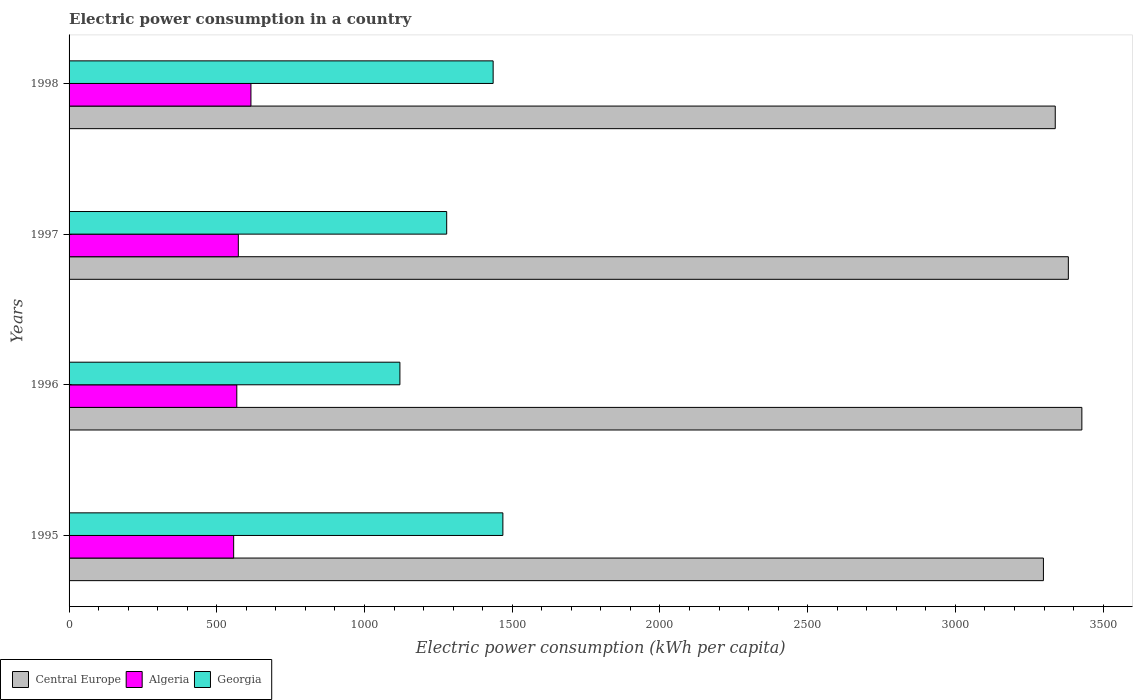How many different coloured bars are there?
Offer a very short reply. 3. How many groups of bars are there?
Your response must be concise. 4. Are the number of bars per tick equal to the number of legend labels?
Your answer should be compact. Yes. Are the number of bars on each tick of the Y-axis equal?
Give a very brief answer. Yes. How many bars are there on the 3rd tick from the bottom?
Offer a terse response. 3. What is the label of the 1st group of bars from the top?
Your response must be concise. 1998. What is the electric power consumption in in Georgia in 1995?
Offer a very short reply. 1468.31. Across all years, what is the maximum electric power consumption in in Georgia?
Make the answer very short. 1468.31. Across all years, what is the minimum electric power consumption in in Algeria?
Your answer should be very brief. 557.08. In which year was the electric power consumption in in Georgia maximum?
Provide a succinct answer. 1995. In which year was the electric power consumption in in Georgia minimum?
Ensure brevity in your answer.  1996. What is the total electric power consumption in in Central Europe in the graph?
Make the answer very short. 1.34e+04. What is the difference between the electric power consumption in in Algeria in 1997 and that in 1998?
Your answer should be compact. -42.64. What is the difference between the electric power consumption in in Central Europe in 1996 and the electric power consumption in in Algeria in 1998?
Offer a terse response. 2812.43. What is the average electric power consumption in in Algeria per year?
Your response must be concise. 578.31. In the year 1998, what is the difference between the electric power consumption in in Algeria and electric power consumption in in Central Europe?
Give a very brief answer. -2722.41. In how many years, is the electric power consumption in in Algeria greater than 2400 kWh per capita?
Provide a succinct answer. 0. What is the ratio of the electric power consumption in in Georgia in 1995 to that in 1998?
Your answer should be compact. 1.02. What is the difference between the highest and the second highest electric power consumption in in Central Europe?
Your answer should be compact. 45.7. What is the difference between the highest and the lowest electric power consumption in in Central Europe?
Provide a short and direct response. 130.07. In how many years, is the electric power consumption in in Georgia greater than the average electric power consumption in in Georgia taken over all years?
Keep it short and to the point. 2. Is the sum of the electric power consumption in in Algeria in 1995 and 1998 greater than the maximum electric power consumption in in Georgia across all years?
Offer a terse response. No. What does the 3rd bar from the top in 1996 represents?
Ensure brevity in your answer.  Central Europe. What does the 2nd bar from the bottom in 1995 represents?
Give a very brief answer. Algeria. Is it the case that in every year, the sum of the electric power consumption in in Central Europe and electric power consumption in in Algeria is greater than the electric power consumption in in Georgia?
Your response must be concise. Yes. How many bars are there?
Your answer should be compact. 12. Are all the bars in the graph horizontal?
Provide a short and direct response. Yes. Does the graph contain any zero values?
Give a very brief answer. No. Does the graph contain grids?
Offer a terse response. No. What is the title of the graph?
Provide a succinct answer. Electric power consumption in a country. Does "Finland" appear as one of the legend labels in the graph?
Your answer should be compact. No. What is the label or title of the X-axis?
Offer a very short reply. Electric power consumption (kWh per capita). What is the Electric power consumption (kWh per capita) of Central Europe in 1995?
Your answer should be very brief. 3297.92. What is the Electric power consumption (kWh per capita) in Algeria in 1995?
Your answer should be compact. 557.08. What is the Electric power consumption (kWh per capita) of Georgia in 1995?
Make the answer very short. 1468.31. What is the Electric power consumption (kWh per capita) of Central Europe in 1996?
Your answer should be very brief. 3427.99. What is the Electric power consumption (kWh per capita) in Algeria in 1996?
Give a very brief answer. 567.7. What is the Electric power consumption (kWh per capita) in Georgia in 1996?
Provide a short and direct response. 1119.78. What is the Electric power consumption (kWh per capita) in Central Europe in 1997?
Your response must be concise. 3382.29. What is the Electric power consumption (kWh per capita) of Algeria in 1997?
Keep it short and to the point. 572.91. What is the Electric power consumption (kWh per capita) of Georgia in 1997?
Provide a succinct answer. 1278.14. What is the Electric power consumption (kWh per capita) of Central Europe in 1998?
Offer a terse response. 3337.97. What is the Electric power consumption (kWh per capita) of Algeria in 1998?
Your answer should be compact. 615.55. What is the Electric power consumption (kWh per capita) in Georgia in 1998?
Ensure brevity in your answer.  1435.38. Across all years, what is the maximum Electric power consumption (kWh per capita) in Central Europe?
Offer a very short reply. 3427.99. Across all years, what is the maximum Electric power consumption (kWh per capita) in Algeria?
Your answer should be very brief. 615.55. Across all years, what is the maximum Electric power consumption (kWh per capita) in Georgia?
Your answer should be very brief. 1468.31. Across all years, what is the minimum Electric power consumption (kWh per capita) in Central Europe?
Your answer should be very brief. 3297.92. Across all years, what is the minimum Electric power consumption (kWh per capita) in Algeria?
Your response must be concise. 557.08. Across all years, what is the minimum Electric power consumption (kWh per capita) in Georgia?
Offer a very short reply. 1119.78. What is the total Electric power consumption (kWh per capita) of Central Europe in the graph?
Make the answer very short. 1.34e+04. What is the total Electric power consumption (kWh per capita) in Algeria in the graph?
Your answer should be very brief. 2313.24. What is the total Electric power consumption (kWh per capita) of Georgia in the graph?
Your answer should be very brief. 5301.61. What is the difference between the Electric power consumption (kWh per capita) in Central Europe in 1995 and that in 1996?
Keep it short and to the point. -130.07. What is the difference between the Electric power consumption (kWh per capita) of Algeria in 1995 and that in 1996?
Your answer should be very brief. -10.62. What is the difference between the Electric power consumption (kWh per capita) in Georgia in 1995 and that in 1996?
Provide a short and direct response. 348.54. What is the difference between the Electric power consumption (kWh per capita) of Central Europe in 1995 and that in 1997?
Offer a terse response. -84.37. What is the difference between the Electric power consumption (kWh per capita) of Algeria in 1995 and that in 1997?
Keep it short and to the point. -15.83. What is the difference between the Electric power consumption (kWh per capita) in Georgia in 1995 and that in 1997?
Offer a very short reply. 190.18. What is the difference between the Electric power consumption (kWh per capita) of Central Europe in 1995 and that in 1998?
Provide a succinct answer. -40.05. What is the difference between the Electric power consumption (kWh per capita) of Algeria in 1995 and that in 1998?
Your response must be concise. -58.47. What is the difference between the Electric power consumption (kWh per capita) of Georgia in 1995 and that in 1998?
Keep it short and to the point. 32.93. What is the difference between the Electric power consumption (kWh per capita) of Central Europe in 1996 and that in 1997?
Ensure brevity in your answer.  45.7. What is the difference between the Electric power consumption (kWh per capita) in Algeria in 1996 and that in 1997?
Your response must be concise. -5.21. What is the difference between the Electric power consumption (kWh per capita) in Georgia in 1996 and that in 1997?
Make the answer very short. -158.36. What is the difference between the Electric power consumption (kWh per capita) of Central Europe in 1996 and that in 1998?
Your answer should be very brief. 90.02. What is the difference between the Electric power consumption (kWh per capita) of Algeria in 1996 and that in 1998?
Offer a terse response. -47.86. What is the difference between the Electric power consumption (kWh per capita) of Georgia in 1996 and that in 1998?
Keep it short and to the point. -315.61. What is the difference between the Electric power consumption (kWh per capita) in Central Europe in 1997 and that in 1998?
Your response must be concise. 44.32. What is the difference between the Electric power consumption (kWh per capita) of Algeria in 1997 and that in 1998?
Your answer should be very brief. -42.64. What is the difference between the Electric power consumption (kWh per capita) of Georgia in 1997 and that in 1998?
Ensure brevity in your answer.  -157.25. What is the difference between the Electric power consumption (kWh per capita) in Central Europe in 1995 and the Electric power consumption (kWh per capita) in Algeria in 1996?
Your answer should be compact. 2730.22. What is the difference between the Electric power consumption (kWh per capita) in Central Europe in 1995 and the Electric power consumption (kWh per capita) in Georgia in 1996?
Your answer should be compact. 2178.14. What is the difference between the Electric power consumption (kWh per capita) in Algeria in 1995 and the Electric power consumption (kWh per capita) in Georgia in 1996?
Make the answer very short. -562.7. What is the difference between the Electric power consumption (kWh per capita) in Central Europe in 1995 and the Electric power consumption (kWh per capita) in Algeria in 1997?
Keep it short and to the point. 2725.01. What is the difference between the Electric power consumption (kWh per capita) in Central Europe in 1995 and the Electric power consumption (kWh per capita) in Georgia in 1997?
Provide a short and direct response. 2019.78. What is the difference between the Electric power consumption (kWh per capita) of Algeria in 1995 and the Electric power consumption (kWh per capita) of Georgia in 1997?
Give a very brief answer. -721.06. What is the difference between the Electric power consumption (kWh per capita) of Central Europe in 1995 and the Electric power consumption (kWh per capita) of Algeria in 1998?
Offer a terse response. 2682.37. What is the difference between the Electric power consumption (kWh per capita) in Central Europe in 1995 and the Electric power consumption (kWh per capita) in Georgia in 1998?
Provide a short and direct response. 1862.54. What is the difference between the Electric power consumption (kWh per capita) of Algeria in 1995 and the Electric power consumption (kWh per capita) of Georgia in 1998?
Give a very brief answer. -878.3. What is the difference between the Electric power consumption (kWh per capita) of Central Europe in 1996 and the Electric power consumption (kWh per capita) of Algeria in 1997?
Provide a succinct answer. 2855.08. What is the difference between the Electric power consumption (kWh per capita) in Central Europe in 1996 and the Electric power consumption (kWh per capita) in Georgia in 1997?
Keep it short and to the point. 2149.85. What is the difference between the Electric power consumption (kWh per capita) of Algeria in 1996 and the Electric power consumption (kWh per capita) of Georgia in 1997?
Provide a short and direct response. -710.44. What is the difference between the Electric power consumption (kWh per capita) in Central Europe in 1996 and the Electric power consumption (kWh per capita) in Algeria in 1998?
Your response must be concise. 2812.43. What is the difference between the Electric power consumption (kWh per capita) of Central Europe in 1996 and the Electric power consumption (kWh per capita) of Georgia in 1998?
Ensure brevity in your answer.  1992.6. What is the difference between the Electric power consumption (kWh per capita) in Algeria in 1996 and the Electric power consumption (kWh per capita) in Georgia in 1998?
Give a very brief answer. -867.69. What is the difference between the Electric power consumption (kWh per capita) of Central Europe in 1997 and the Electric power consumption (kWh per capita) of Algeria in 1998?
Keep it short and to the point. 2766.73. What is the difference between the Electric power consumption (kWh per capita) of Central Europe in 1997 and the Electric power consumption (kWh per capita) of Georgia in 1998?
Make the answer very short. 1946.9. What is the difference between the Electric power consumption (kWh per capita) in Algeria in 1997 and the Electric power consumption (kWh per capita) in Georgia in 1998?
Your response must be concise. -862.47. What is the average Electric power consumption (kWh per capita) of Central Europe per year?
Your answer should be compact. 3361.54. What is the average Electric power consumption (kWh per capita) of Algeria per year?
Give a very brief answer. 578.31. What is the average Electric power consumption (kWh per capita) of Georgia per year?
Offer a very short reply. 1325.4. In the year 1995, what is the difference between the Electric power consumption (kWh per capita) of Central Europe and Electric power consumption (kWh per capita) of Algeria?
Provide a short and direct response. 2740.84. In the year 1995, what is the difference between the Electric power consumption (kWh per capita) of Central Europe and Electric power consumption (kWh per capita) of Georgia?
Your answer should be very brief. 1829.61. In the year 1995, what is the difference between the Electric power consumption (kWh per capita) of Algeria and Electric power consumption (kWh per capita) of Georgia?
Ensure brevity in your answer.  -911.23. In the year 1996, what is the difference between the Electric power consumption (kWh per capita) in Central Europe and Electric power consumption (kWh per capita) in Algeria?
Your answer should be very brief. 2860.29. In the year 1996, what is the difference between the Electric power consumption (kWh per capita) of Central Europe and Electric power consumption (kWh per capita) of Georgia?
Offer a terse response. 2308.21. In the year 1996, what is the difference between the Electric power consumption (kWh per capita) of Algeria and Electric power consumption (kWh per capita) of Georgia?
Give a very brief answer. -552.08. In the year 1997, what is the difference between the Electric power consumption (kWh per capita) of Central Europe and Electric power consumption (kWh per capita) of Algeria?
Your answer should be compact. 2809.38. In the year 1997, what is the difference between the Electric power consumption (kWh per capita) of Central Europe and Electric power consumption (kWh per capita) of Georgia?
Offer a very short reply. 2104.15. In the year 1997, what is the difference between the Electric power consumption (kWh per capita) in Algeria and Electric power consumption (kWh per capita) in Georgia?
Ensure brevity in your answer.  -705.22. In the year 1998, what is the difference between the Electric power consumption (kWh per capita) in Central Europe and Electric power consumption (kWh per capita) in Algeria?
Your answer should be very brief. 2722.41. In the year 1998, what is the difference between the Electric power consumption (kWh per capita) in Central Europe and Electric power consumption (kWh per capita) in Georgia?
Provide a succinct answer. 1902.58. In the year 1998, what is the difference between the Electric power consumption (kWh per capita) of Algeria and Electric power consumption (kWh per capita) of Georgia?
Provide a succinct answer. -819.83. What is the ratio of the Electric power consumption (kWh per capita) in Central Europe in 1995 to that in 1996?
Offer a terse response. 0.96. What is the ratio of the Electric power consumption (kWh per capita) of Algeria in 1995 to that in 1996?
Offer a very short reply. 0.98. What is the ratio of the Electric power consumption (kWh per capita) of Georgia in 1995 to that in 1996?
Offer a terse response. 1.31. What is the ratio of the Electric power consumption (kWh per capita) in Central Europe in 1995 to that in 1997?
Ensure brevity in your answer.  0.98. What is the ratio of the Electric power consumption (kWh per capita) in Algeria in 1995 to that in 1997?
Make the answer very short. 0.97. What is the ratio of the Electric power consumption (kWh per capita) in Georgia in 1995 to that in 1997?
Offer a terse response. 1.15. What is the ratio of the Electric power consumption (kWh per capita) of Algeria in 1995 to that in 1998?
Your response must be concise. 0.91. What is the ratio of the Electric power consumption (kWh per capita) of Georgia in 1995 to that in 1998?
Provide a short and direct response. 1.02. What is the ratio of the Electric power consumption (kWh per capita) in Central Europe in 1996 to that in 1997?
Offer a terse response. 1.01. What is the ratio of the Electric power consumption (kWh per capita) of Algeria in 1996 to that in 1997?
Provide a succinct answer. 0.99. What is the ratio of the Electric power consumption (kWh per capita) of Georgia in 1996 to that in 1997?
Provide a short and direct response. 0.88. What is the ratio of the Electric power consumption (kWh per capita) of Central Europe in 1996 to that in 1998?
Offer a very short reply. 1.03. What is the ratio of the Electric power consumption (kWh per capita) of Algeria in 1996 to that in 1998?
Offer a very short reply. 0.92. What is the ratio of the Electric power consumption (kWh per capita) of Georgia in 1996 to that in 1998?
Your response must be concise. 0.78. What is the ratio of the Electric power consumption (kWh per capita) of Central Europe in 1997 to that in 1998?
Ensure brevity in your answer.  1.01. What is the ratio of the Electric power consumption (kWh per capita) of Algeria in 1997 to that in 1998?
Give a very brief answer. 0.93. What is the ratio of the Electric power consumption (kWh per capita) in Georgia in 1997 to that in 1998?
Your response must be concise. 0.89. What is the difference between the highest and the second highest Electric power consumption (kWh per capita) in Central Europe?
Offer a terse response. 45.7. What is the difference between the highest and the second highest Electric power consumption (kWh per capita) in Algeria?
Your answer should be very brief. 42.64. What is the difference between the highest and the second highest Electric power consumption (kWh per capita) of Georgia?
Keep it short and to the point. 32.93. What is the difference between the highest and the lowest Electric power consumption (kWh per capita) of Central Europe?
Provide a short and direct response. 130.07. What is the difference between the highest and the lowest Electric power consumption (kWh per capita) of Algeria?
Ensure brevity in your answer.  58.47. What is the difference between the highest and the lowest Electric power consumption (kWh per capita) in Georgia?
Your response must be concise. 348.54. 